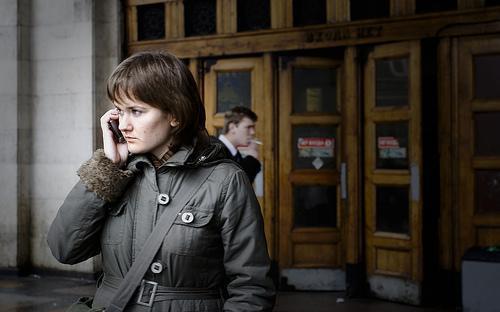How many people are in this picture?
Give a very brief answer. 2. 